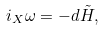Convert formula to latex. <formula><loc_0><loc_0><loc_500><loc_500>i _ { X } \omega = - d \tilde { H } ,</formula> 